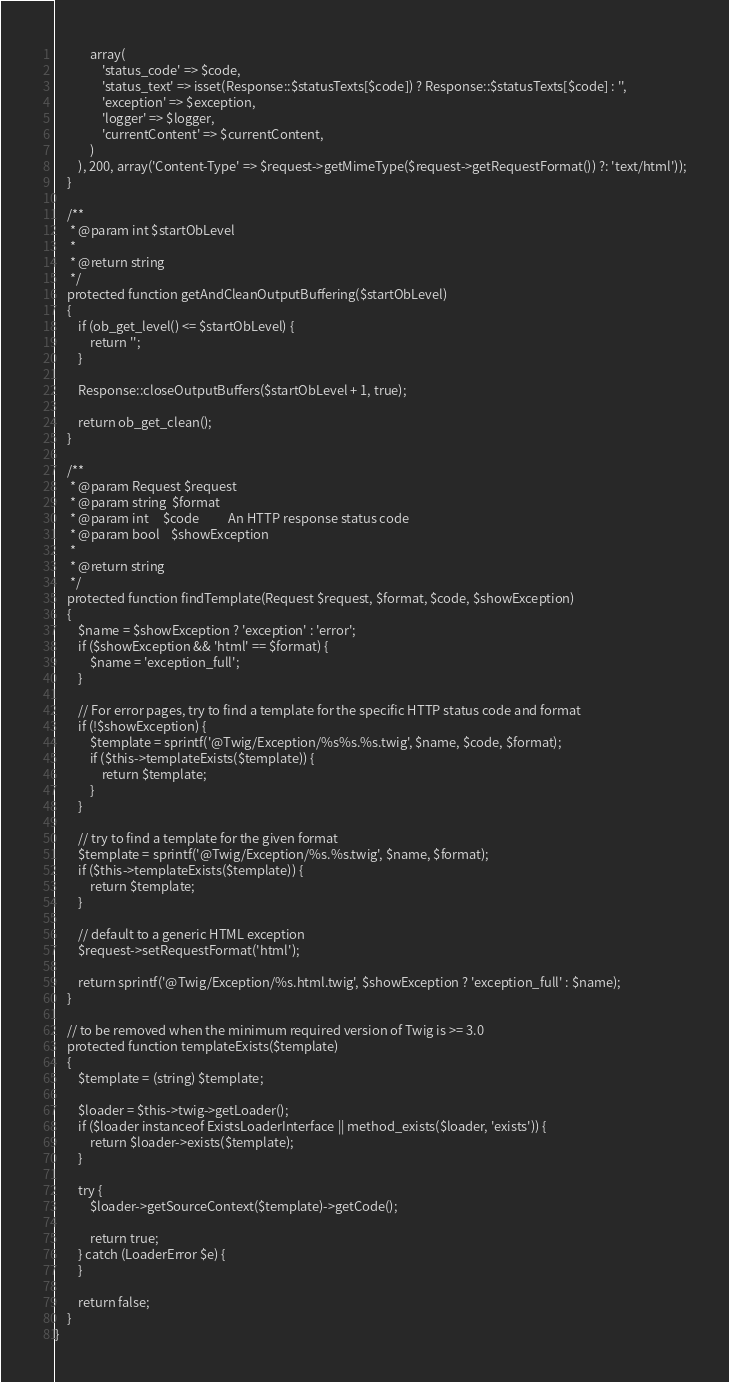<code> <loc_0><loc_0><loc_500><loc_500><_PHP_>            array(
                'status_code' => $code,
                'status_text' => isset(Response::$statusTexts[$code]) ? Response::$statusTexts[$code] : '',
                'exception' => $exception,
                'logger' => $logger,
                'currentContent' => $currentContent,
            )
        ), 200, array('Content-Type' => $request->getMimeType($request->getRequestFormat()) ?: 'text/html'));
    }

    /**
     * @param int $startObLevel
     *
     * @return string
     */
    protected function getAndCleanOutputBuffering($startObLevel)
    {
        if (ob_get_level() <= $startObLevel) {
            return '';
        }

        Response::closeOutputBuffers($startObLevel + 1, true);

        return ob_get_clean();
    }

    /**
     * @param Request $request
     * @param string  $format
     * @param int     $code          An HTTP response status code
     * @param bool    $showException
     *
     * @return string
     */
    protected function findTemplate(Request $request, $format, $code, $showException)
    {
        $name = $showException ? 'exception' : 'error';
        if ($showException && 'html' == $format) {
            $name = 'exception_full';
        }

        // For error pages, try to find a template for the specific HTTP status code and format
        if (!$showException) {
            $template = sprintf('@Twig/Exception/%s%s.%s.twig', $name, $code, $format);
            if ($this->templateExists($template)) {
                return $template;
            }
        }

        // try to find a template for the given format
        $template = sprintf('@Twig/Exception/%s.%s.twig', $name, $format);
        if ($this->templateExists($template)) {
            return $template;
        }

        // default to a generic HTML exception
        $request->setRequestFormat('html');

        return sprintf('@Twig/Exception/%s.html.twig', $showException ? 'exception_full' : $name);
    }

    // to be removed when the minimum required version of Twig is >= 3.0
    protected function templateExists($template)
    {
        $template = (string) $template;

        $loader = $this->twig->getLoader();
        if ($loader instanceof ExistsLoaderInterface || method_exists($loader, 'exists')) {
            return $loader->exists($template);
        }

        try {
            $loader->getSourceContext($template)->getCode();

            return true;
        } catch (LoaderError $e) {
        }

        return false;
    }
}
</code> 